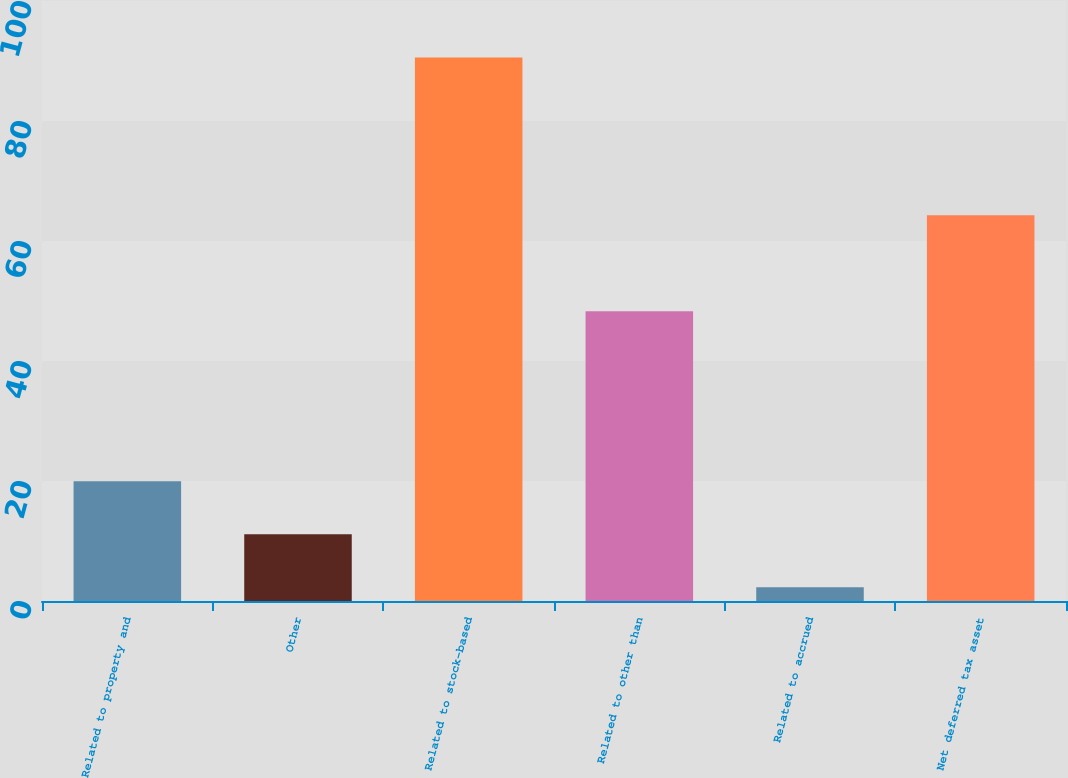<chart> <loc_0><loc_0><loc_500><loc_500><bar_chart><fcel>Related to property and<fcel>Other<fcel>Related to stock-based<fcel>Related to other than<fcel>Related to accrued<fcel>Net deferred tax asset<nl><fcel>19.96<fcel>11.13<fcel>90.6<fcel>48.3<fcel>2.3<fcel>64.3<nl></chart> 